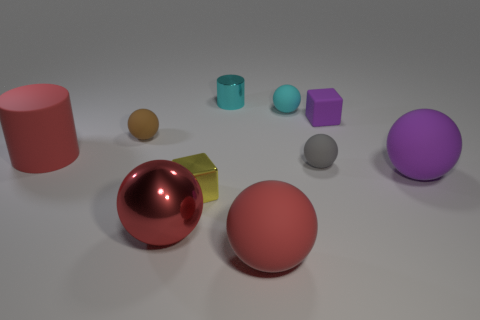Subtract all brown spheres. How many spheres are left? 5 Subtract all cyan cylinders. How many cylinders are left? 1 Subtract all cylinders. How many objects are left? 8 Subtract 2 cylinders. How many cylinders are left? 0 Subtract 1 red cylinders. How many objects are left? 9 Subtract all red spheres. Subtract all yellow cylinders. How many spheres are left? 4 Subtract all green cubes. How many yellow cylinders are left? 0 Subtract all big red metallic things. Subtract all large metallic things. How many objects are left? 8 Add 9 small yellow blocks. How many small yellow blocks are left? 10 Add 5 yellow cubes. How many yellow cubes exist? 6 